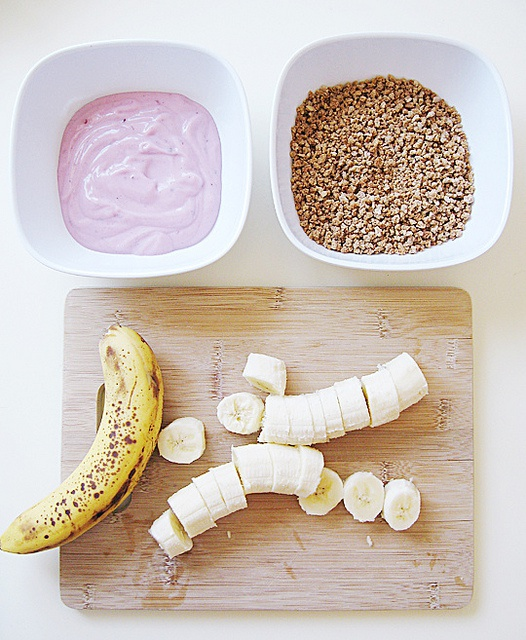Describe the objects in this image and their specific colors. I can see bowl in lightgray, black, maroon, and brown tones, bowl in lightgray, lavender, pink, and lightpink tones, banana in lightgray, beige, khaki, and gold tones, banana in lightgray, white, and tan tones, and banana in lightgray, white, and tan tones in this image. 